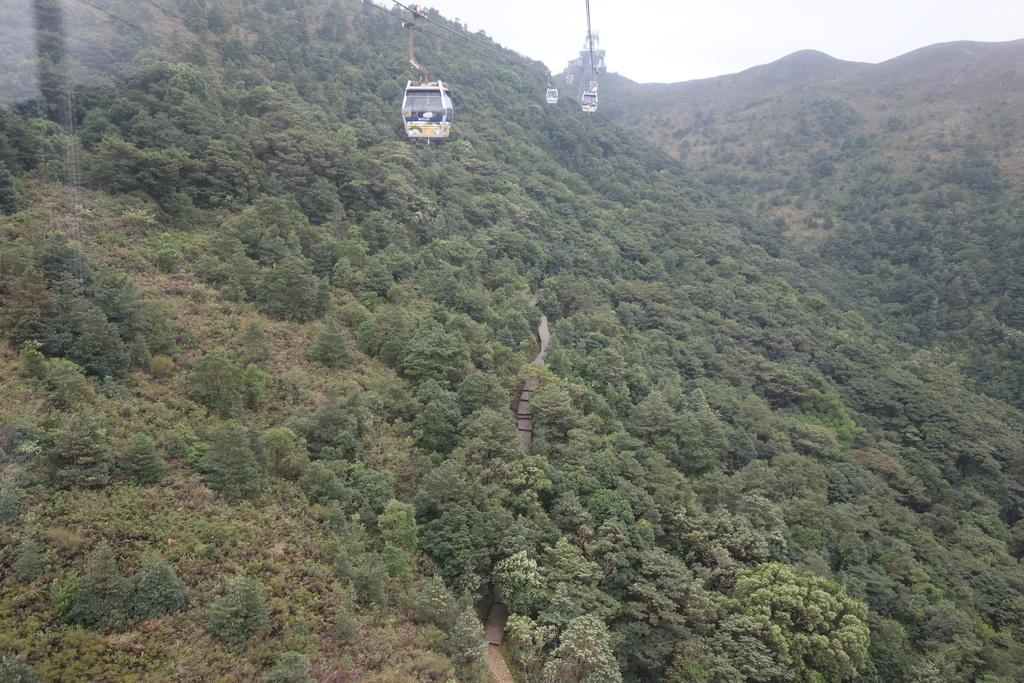What type of transportation is shown in the image? There is a ropeway in the image. What natural elements can be seen in the image? There are trees and hills visible in the image. Is there a path or road visible in the image? Yes, there is a path visible in the image. What is the reflection on the left side of the image? The reflection on the left side of the image is possibly on glass. What is visible in the sky in the image? The sky is visible in the image. What type of pollution can be seen in the image? There is no pollution visible in the image. How many people are in the group shown in the image? There is no group of people present in the image. 